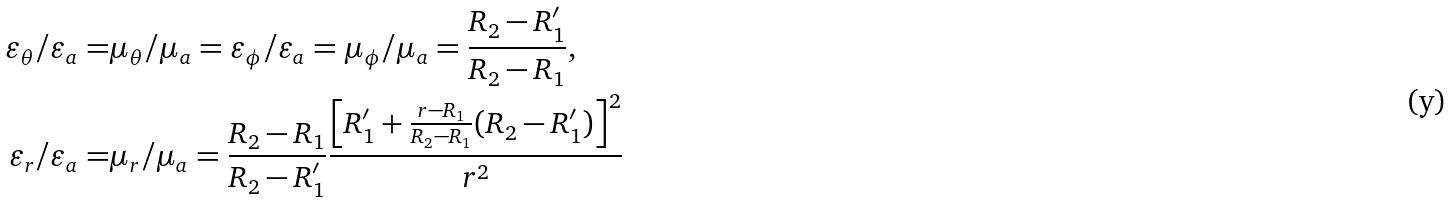Convert formula to latex. <formula><loc_0><loc_0><loc_500><loc_500>\varepsilon _ { \theta } / \varepsilon _ { a } = & \mu _ { \theta } / \mu _ { a } = \varepsilon _ { \phi } / \varepsilon _ { a } = \mu _ { \phi } / \mu _ { a } = \frac { R _ { 2 } - R _ { 1 } ^ { \prime } } { R _ { 2 } - R _ { 1 } } , \\ \varepsilon _ { r } / \varepsilon _ { a } = & \mu _ { r } / \mu _ { a } = \frac { R _ { 2 } - R _ { 1 } } { R _ { 2 } - R _ { 1 } ^ { \prime } } \frac { \left [ R _ { 1 } ^ { \prime } + \frac { r - R _ { 1 } } { R _ { 2 } - R _ { 1 } } ( R _ { 2 } - R _ { 1 } ^ { \prime } ) \right ] ^ { 2 } } { r ^ { 2 } }</formula> 